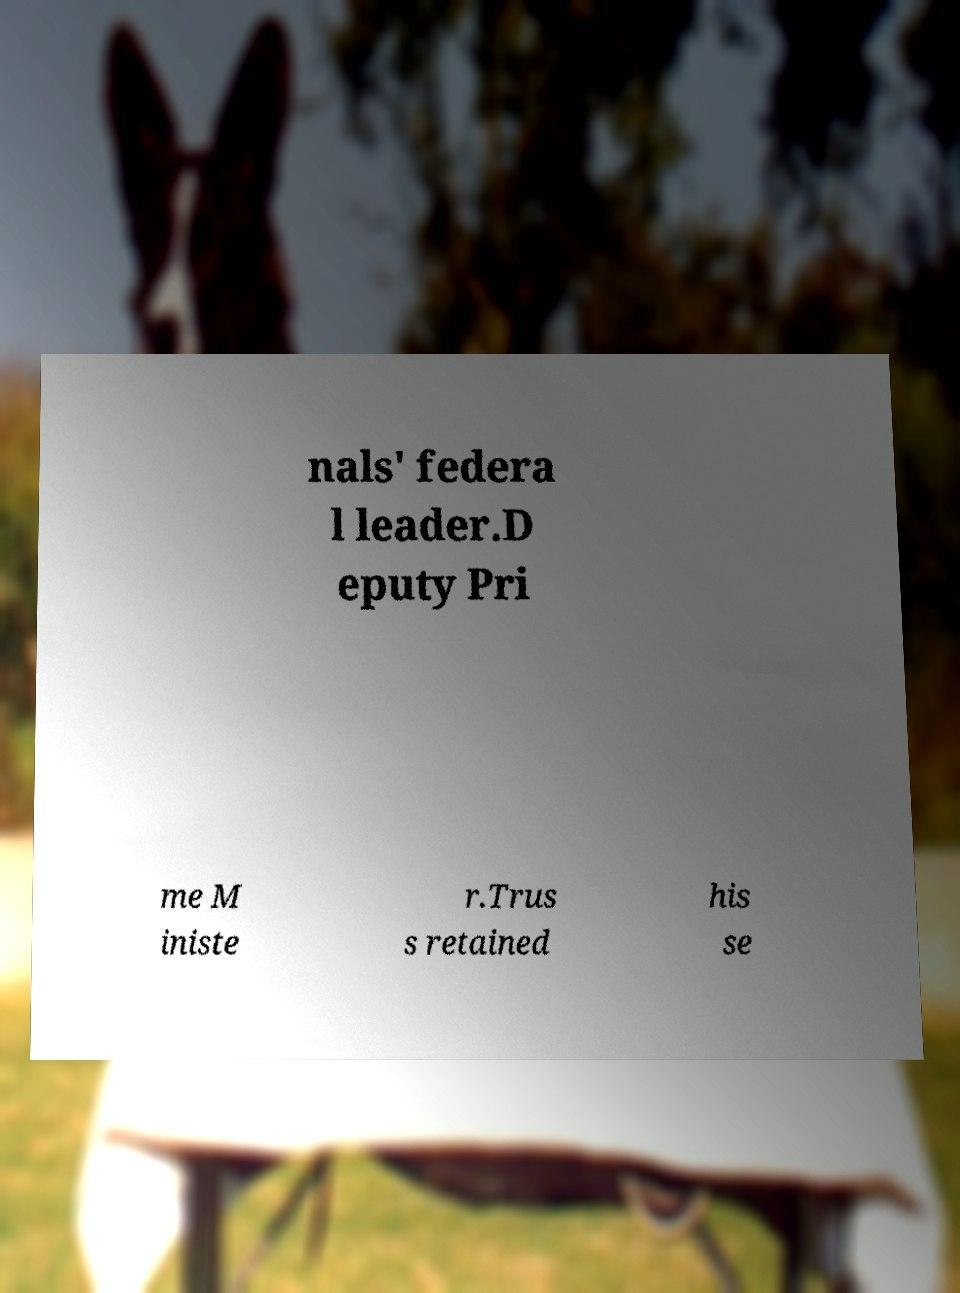There's text embedded in this image that I need extracted. Can you transcribe it verbatim? nals' federa l leader.D eputy Pri me M iniste r.Trus s retained his se 